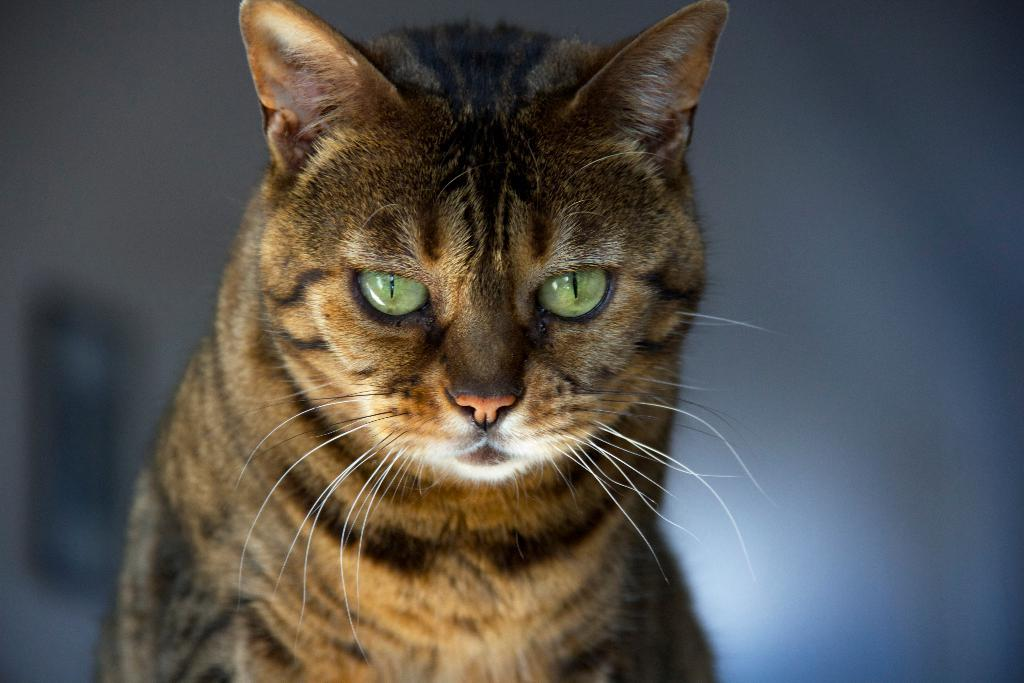What is the main subject in the center of the image? There is a cat in the center of the image. Can you describe the background of the image? The background of the image is blurred. Is the cat holding an umbrella in the image? There is no umbrella present in the image. Can you hear the cat crying in the image? The image is a visual representation, so it does not include any sounds or audio. How many people are visible in the image? There are no people visible in the image; it features a cat. 